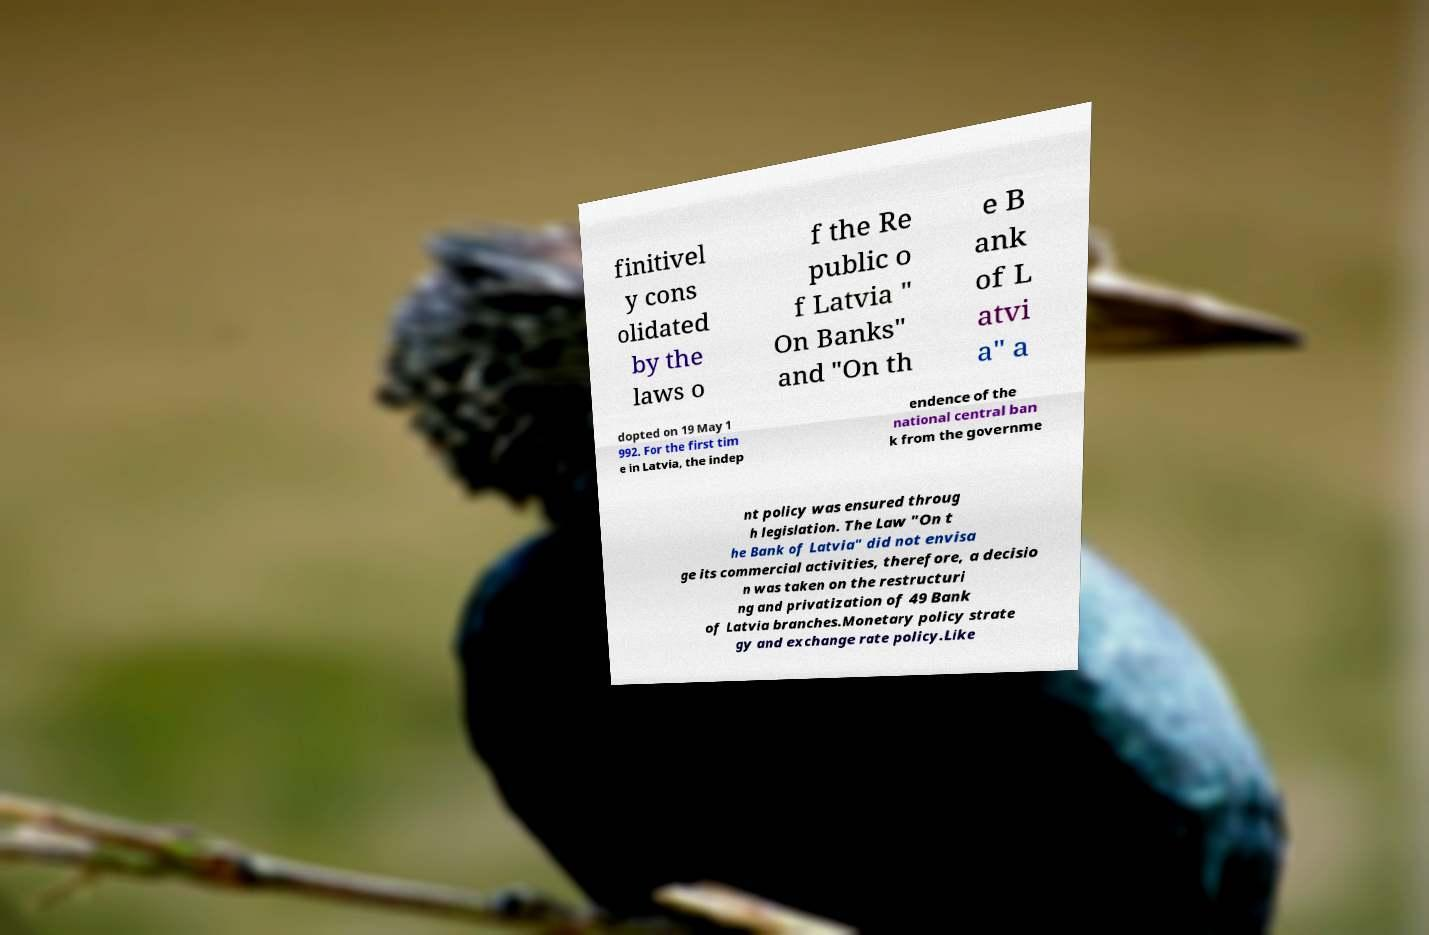What messages or text are displayed in this image? I need them in a readable, typed format. finitivel y cons olidated by the laws o f the Re public o f Latvia " On Banks" and "On th e B ank of L atvi a" a dopted on 19 May 1 992. For the first tim e in Latvia, the indep endence of the national central ban k from the governme nt policy was ensured throug h legislation. The Law "On t he Bank of Latvia" did not envisa ge its commercial activities, therefore, a decisio n was taken on the restructuri ng and privatization of 49 Bank of Latvia branches.Monetary policy strate gy and exchange rate policy.Like 